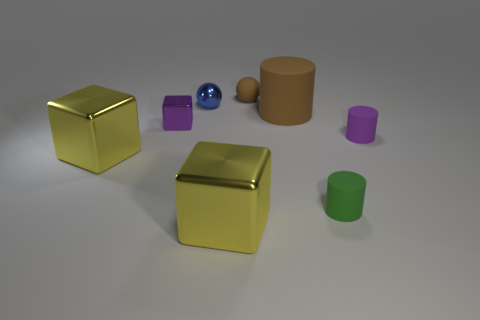Subtract all purple rubber cylinders. How many cylinders are left? 2 Add 2 tiny purple matte cylinders. How many objects exist? 10 Subtract all brown balls. How many balls are left? 1 Subtract 2 yellow cubes. How many objects are left? 6 Subtract all balls. How many objects are left? 6 Subtract 3 cubes. How many cubes are left? 0 Subtract all blue cubes. Subtract all cyan spheres. How many cubes are left? 3 Subtract all yellow cylinders. How many blue spheres are left? 1 Subtract all matte balls. Subtract all tiny cylinders. How many objects are left? 5 Add 3 tiny metal blocks. How many tiny metal blocks are left? 4 